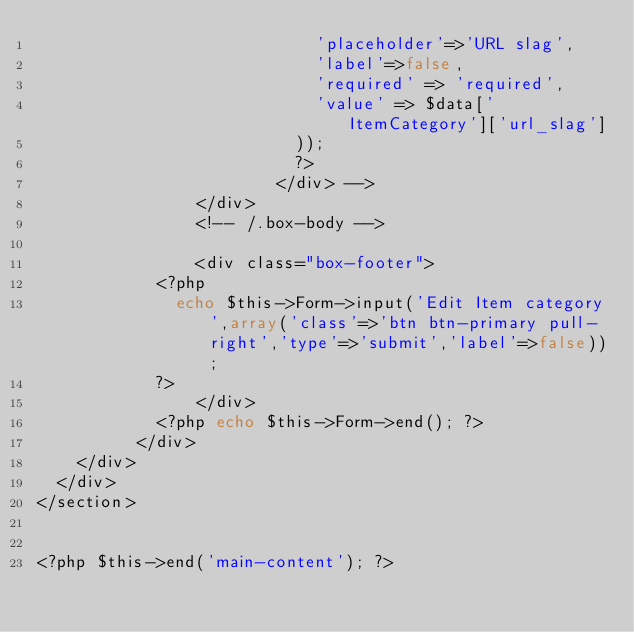Convert code to text. <code><loc_0><loc_0><loc_500><loc_500><_PHP_>                            'placeholder'=>'URL slag',
                            'label'=>false,
                            'required' => 'required',
                            'value' => $data['ItemCategory']['url_slag']
                          ));
                          ?>
                        </div> -->
	            	</div>
	              <!-- /.box-body -->

		            <div class="box-footer">
						<?php
							echo $this->Form->input('Edit Item category',array('class'=>'btn btn-primary pull-right','type'=>'submit','label'=>false));
						?>
		            </div>
				  	<?php echo $this->Form->end(); ?>
	        </div>
		</div>
	</div>
</section>


<?php $this->end('main-content'); ?>
</code> 